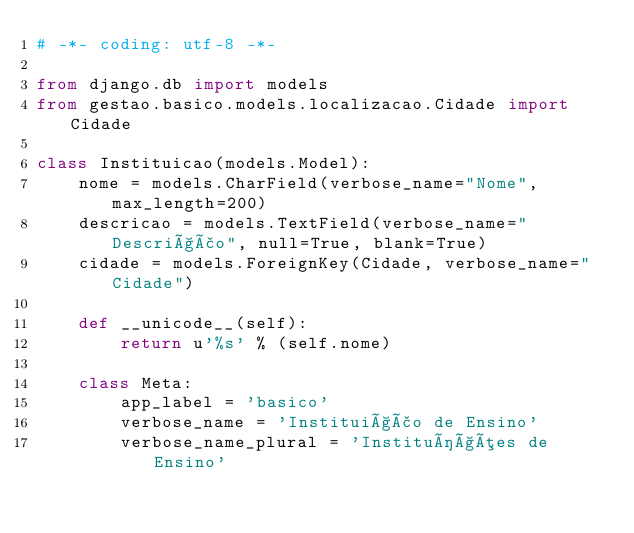<code> <loc_0><loc_0><loc_500><loc_500><_Python_># -*- coding: utf-8 -*-

from django.db import models
from gestao.basico.models.localizacao.Cidade import Cidade

class Instituicao(models.Model):
    nome = models.CharField(verbose_name="Nome", max_length=200)
    descricao = models.TextField(verbose_name="Descrição", null=True, blank=True)
    cidade = models.ForeignKey(Cidade, verbose_name="Cidade")
    
    def __unicode__(self):
        return u'%s' % (self.nome)
                    
    class Meta:
        app_label = 'basico'
        verbose_name = 'Instituição de Ensino'
        verbose_name_plural = 'Instituíções de Ensino'
    
    
        </code> 